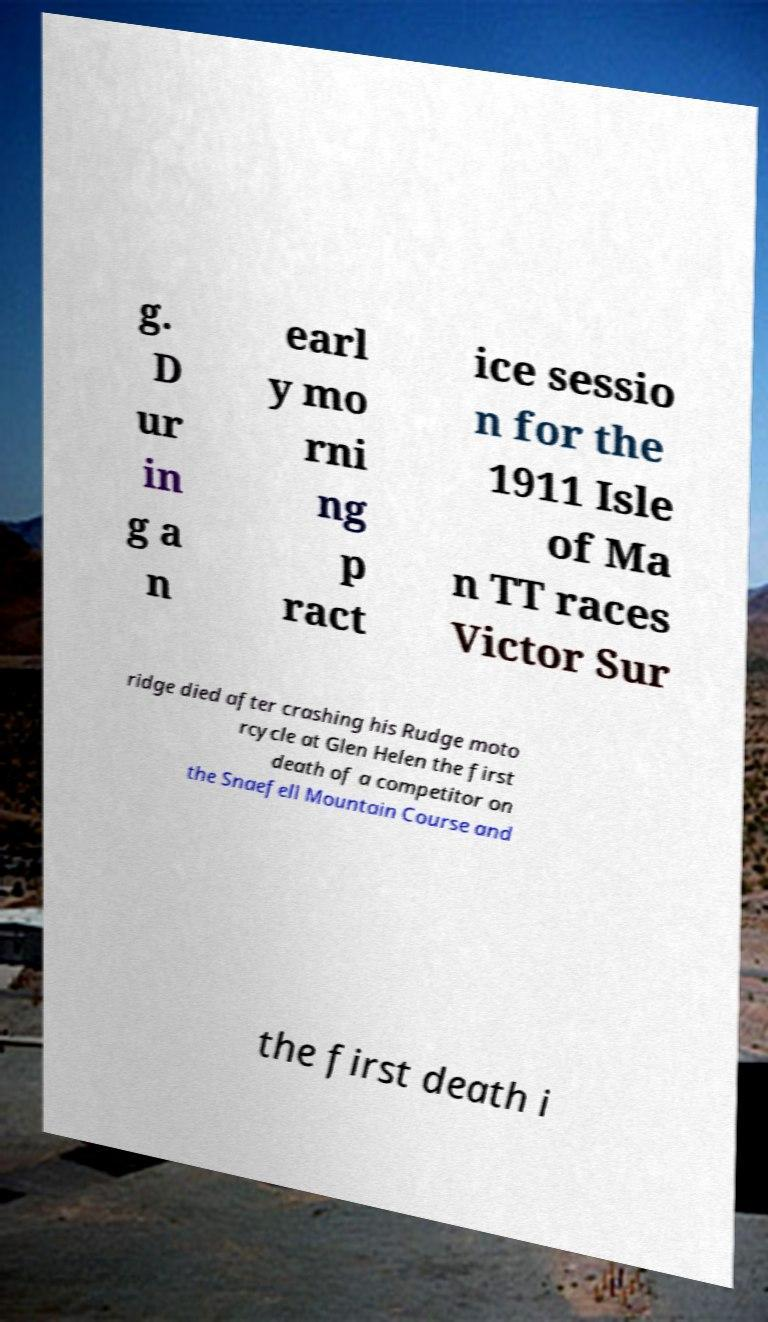I need the written content from this picture converted into text. Can you do that? g. D ur in g a n earl y mo rni ng p ract ice sessio n for the 1911 Isle of Ma n TT races Victor Sur ridge died after crashing his Rudge moto rcycle at Glen Helen the first death of a competitor on the Snaefell Mountain Course and the first death i 